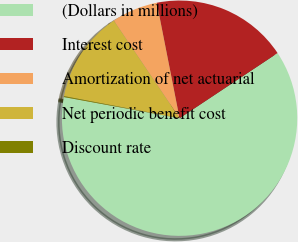Convert chart to OTSL. <chart><loc_0><loc_0><loc_500><loc_500><pie_chart><fcel>(Dollars in millions)<fcel>Interest cost<fcel>Amortization of net actuarial<fcel>Net periodic benefit cost<fcel>Discount rate<nl><fcel>62.21%<fcel>18.76%<fcel>6.34%<fcel>12.55%<fcel>0.13%<nl></chart> 